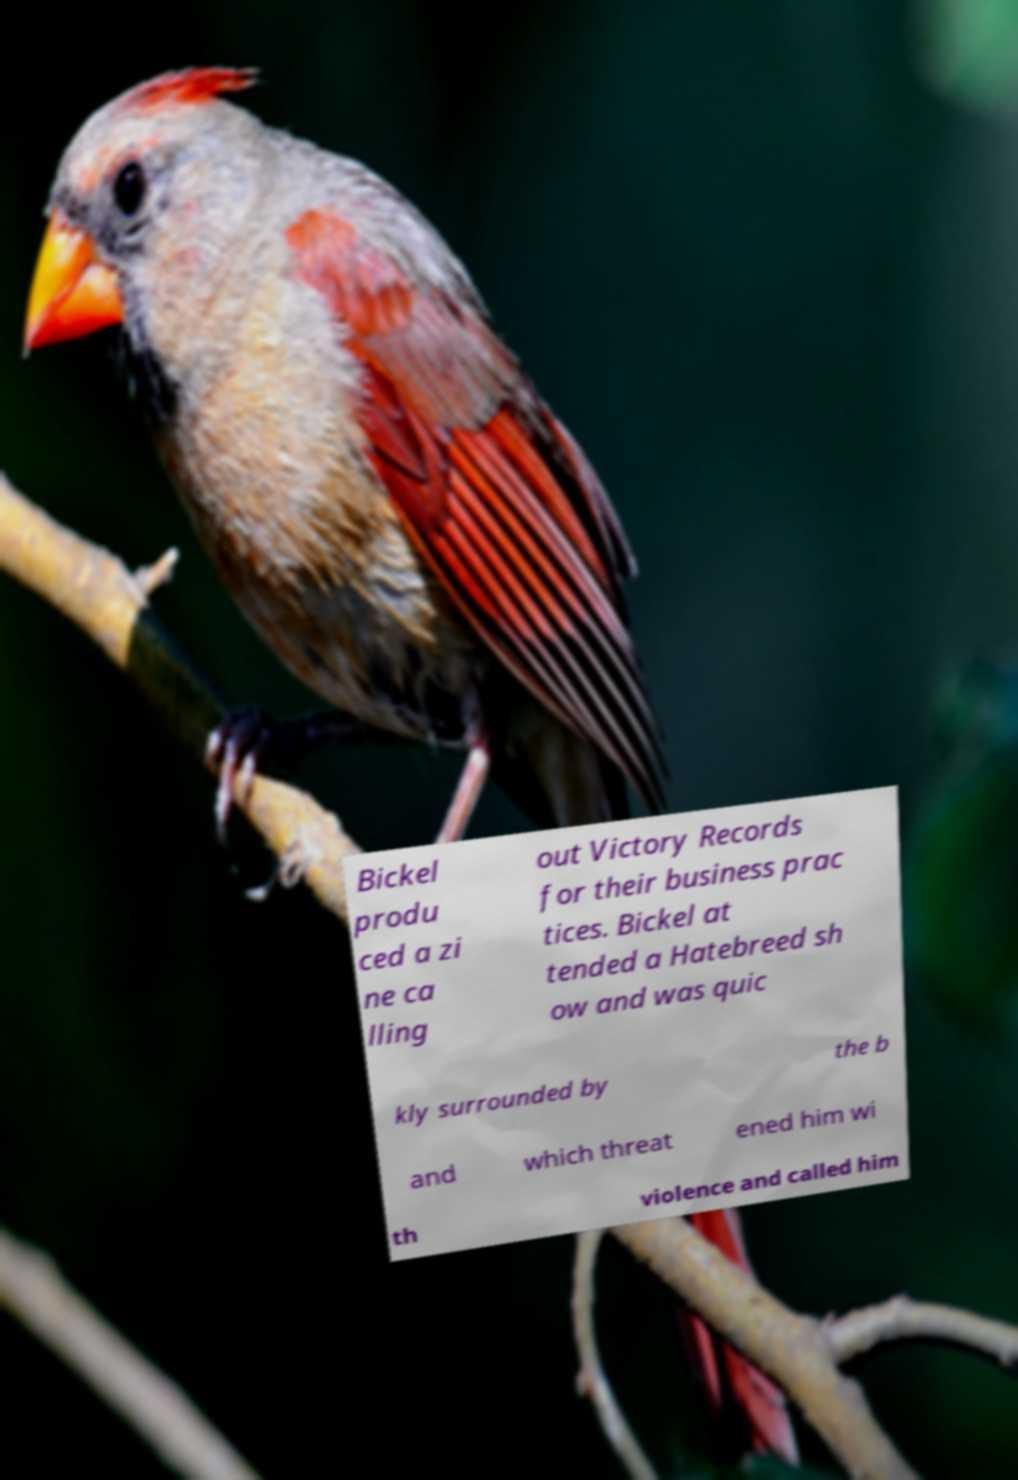Please identify and transcribe the text found in this image. Bickel produ ced a zi ne ca lling out Victory Records for their business prac tices. Bickel at tended a Hatebreed sh ow and was quic kly surrounded by the b and which threat ened him wi th violence and called him 